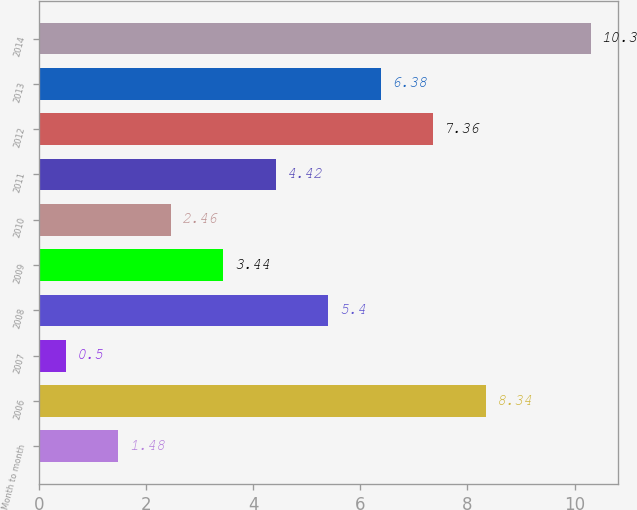Convert chart to OTSL. <chart><loc_0><loc_0><loc_500><loc_500><bar_chart><fcel>Month to month<fcel>2006<fcel>2007<fcel>2008<fcel>2009<fcel>2010<fcel>2011<fcel>2012<fcel>2013<fcel>2014<nl><fcel>1.48<fcel>8.34<fcel>0.5<fcel>5.4<fcel>3.44<fcel>2.46<fcel>4.42<fcel>7.36<fcel>6.38<fcel>10.3<nl></chart> 